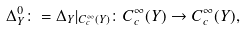<formula> <loc_0><loc_0><loc_500><loc_500>\Delta _ { Y } ^ { 0 } \colon = \Delta _ { Y } | _ { C _ { c } ^ { \infty } ( Y ) } \colon C _ { c } ^ { \infty } ( Y ) \rightarrow C _ { c } ^ { \infty } ( Y ) ,</formula> 